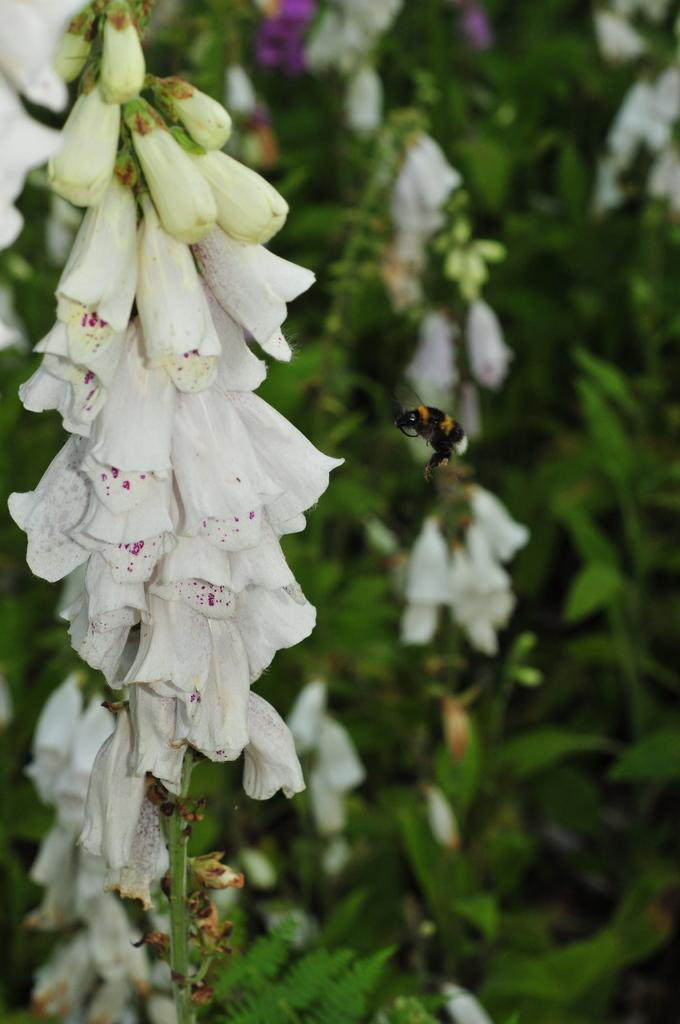What type of plants can be seen in the image? There are flowering plants in the image. What insect is present in the image? There is a bee in the image. Can you determine the time of day when the image was taken? Yes, the image was taken during the day. What type of texture can be seen on the trees in the image? There are no trees present in the image, only flowering plants. What type of humor is being displayed by the bee in the image? The image does not depict any humor; it is a photograph of a bee and flowering plants. 